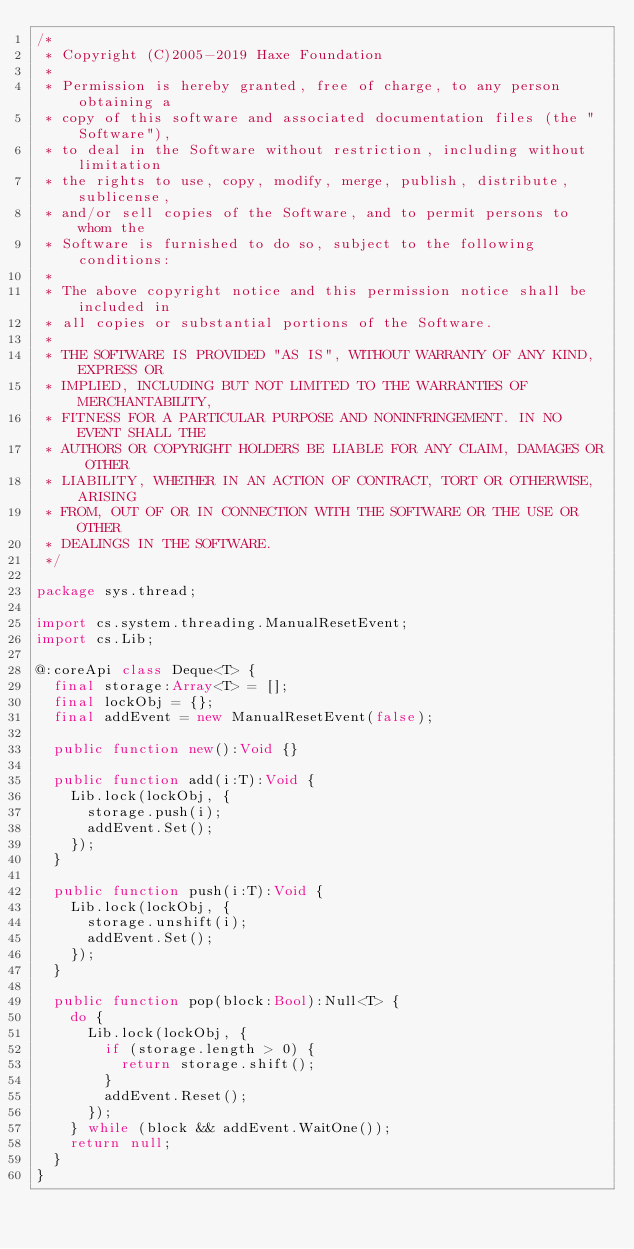Convert code to text. <code><loc_0><loc_0><loc_500><loc_500><_Haxe_>/*
 * Copyright (C)2005-2019 Haxe Foundation
 *
 * Permission is hereby granted, free of charge, to any person obtaining a
 * copy of this software and associated documentation files (the "Software"),
 * to deal in the Software without restriction, including without limitation
 * the rights to use, copy, modify, merge, publish, distribute, sublicense,
 * and/or sell copies of the Software, and to permit persons to whom the
 * Software is furnished to do so, subject to the following conditions:
 *
 * The above copyright notice and this permission notice shall be included in
 * all copies or substantial portions of the Software.
 *
 * THE SOFTWARE IS PROVIDED "AS IS", WITHOUT WARRANTY OF ANY KIND, EXPRESS OR
 * IMPLIED, INCLUDING BUT NOT LIMITED TO THE WARRANTIES OF MERCHANTABILITY,
 * FITNESS FOR A PARTICULAR PURPOSE AND NONINFRINGEMENT. IN NO EVENT SHALL THE
 * AUTHORS OR COPYRIGHT HOLDERS BE LIABLE FOR ANY CLAIM, DAMAGES OR OTHER
 * LIABILITY, WHETHER IN AN ACTION OF CONTRACT, TORT OR OTHERWISE, ARISING
 * FROM, OUT OF OR IN CONNECTION WITH THE SOFTWARE OR THE USE OR OTHER
 * DEALINGS IN THE SOFTWARE.
 */

package sys.thread;

import cs.system.threading.ManualResetEvent;
import cs.Lib;

@:coreApi class Deque<T> {
	final storage:Array<T> = [];
	final lockObj = {};
	final addEvent = new ManualResetEvent(false);

	public function new():Void {}

	public function add(i:T):Void {
		Lib.lock(lockObj, {
			storage.push(i);
			addEvent.Set();
		});
	}

	public function push(i:T):Void {
		Lib.lock(lockObj, {
			storage.unshift(i);
			addEvent.Set();
		});
	}

	public function pop(block:Bool):Null<T> {
		do {
			Lib.lock(lockObj, {
				if (storage.length > 0) {
					return storage.shift();
				}
				addEvent.Reset();
			});
		} while (block && addEvent.WaitOne());
		return null;
	}
}
</code> 